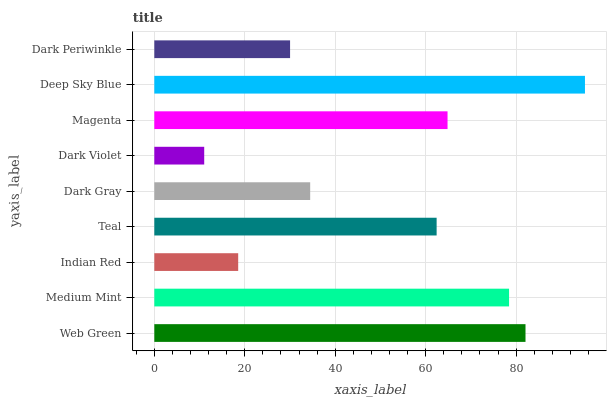Is Dark Violet the minimum?
Answer yes or no. Yes. Is Deep Sky Blue the maximum?
Answer yes or no. Yes. Is Medium Mint the minimum?
Answer yes or no. No. Is Medium Mint the maximum?
Answer yes or no. No. Is Web Green greater than Medium Mint?
Answer yes or no. Yes. Is Medium Mint less than Web Green?
Answer yes or no. Yes. Is Medium Mint greater than Web Green?
Answer yes or no. No. Is Web Green less than Medium Mint?
Answer yes or no. No. Is Teal the high median?
Answer yes or no. Yes. Is Teal the low median?
Answer yes or no. Yes. Is Web Green the high median?
Answer yes or no. No. Is Medium Mint the low median?
Answer yes or no. No. 